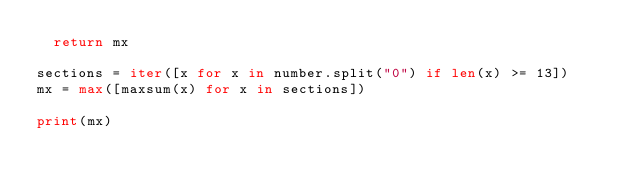<code> <loc_0><loc_0><loc_500><loc_500><_Python_>  return mx

sections = iter([x for x in number.split("0") if len(x) >= 13])
mx = max([maxsum(x) for x in sections])

print(mx)
</code> 